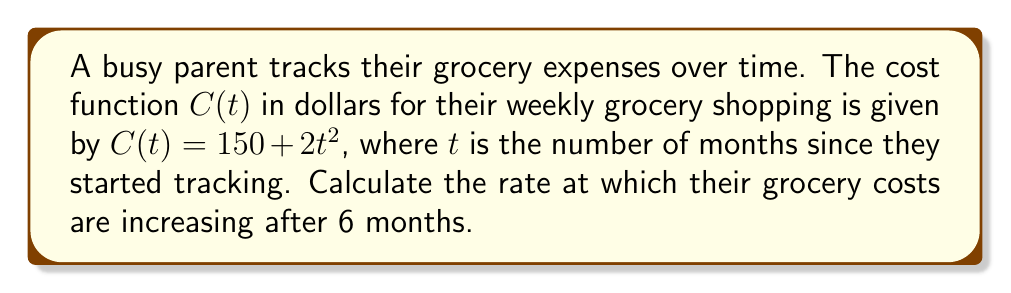Can you answer this question? To find the rate at which grocery costs are increasing after 6 months, we need to calculate the derivative of the cost function $C(t)$ and evaluate it at $t=6$. Here's the step-by-step process:

1) The cost function is given as:
   $C(t) = 150 + 2t^2$

2) To find the rate of change, we need to calculate $\frac{dC}{dt}$:
   $\frac{dC}{dt} = \frac{d}{dt}(150 + 2t^2)$

3) Using the power rule of differentiation:
   $\frac{dC}{dt} = 0 + 2 \cdot 2t = 4t$

4) Now, we evaluate this at $t=6$:
   $\frac{dC}{dt}\bigg|_{t=6} = 4(6) = 24$

Therefore, after 6 months, the grocery costs are increasing at a rate of $24 per month.
Answer: $24 per month 